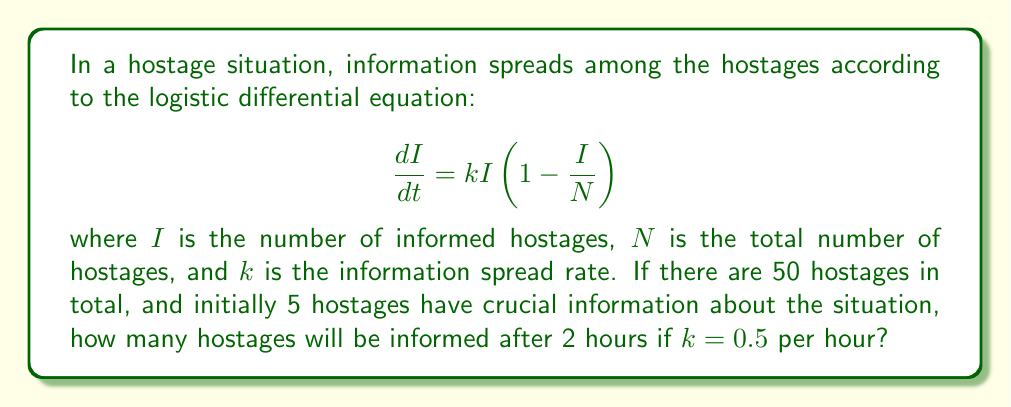What is the answer to this math problem? To solve this problem, we need to use the solution to the logistic differential equation:

1) The solution to the logistic equation is given by:

   $$I(t) = \frac{N}{1 + (\frac{N}{I_0} - 1)e^{-kt}}$$

   where $I_0$ is the initial number of informed hostages.

2) We are given:
   $N = 50$ (total hostages)
   $I_0 = 5$ (initially informed hostages)
   $k = 0.5$ per hour
   $t = 2$ hours

3) Substituting these values into the equation:

   $$I(2) = \frac{50}{1 + (\frac{50}{5} - 1)e^{-0.5 \cdot 2}}$$

4) Simplify:
   $$I(2) = \frac{50}{1 + 9e^{-1}}$$

5) Calculate:
   $$I(2) = \frac{50}{1 + 9/e} \approx 31.62$$

6) Since we're dealing with whole people, we round down to the nearest integer.
Answer: 31 hostages 